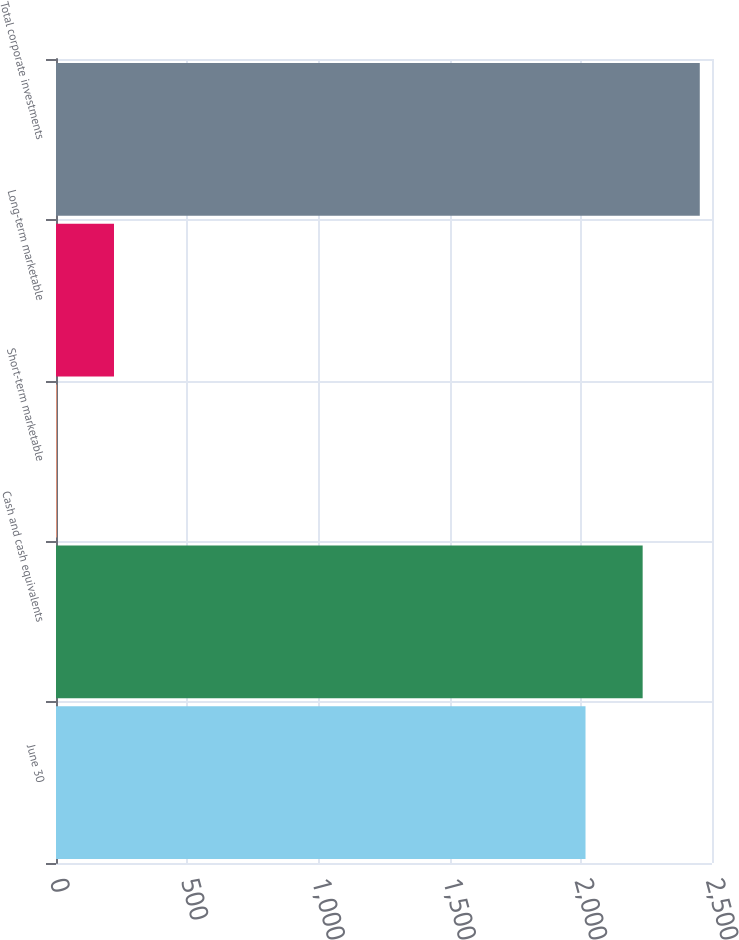Convert chart to OTSL. <chart><loc_0><loc_0><loc_500><loc_500><bar_chart><fcel>June 30<fcel>Cash and cash equivalents<fcel>Short-term marketable<fcel>Long-term marketable<fcel>Total corporate investments<nl><fcel>2018<fcel>2235.72<fcel>3.3<fcel>221.02<fcel>2453.44<nl></chart> 